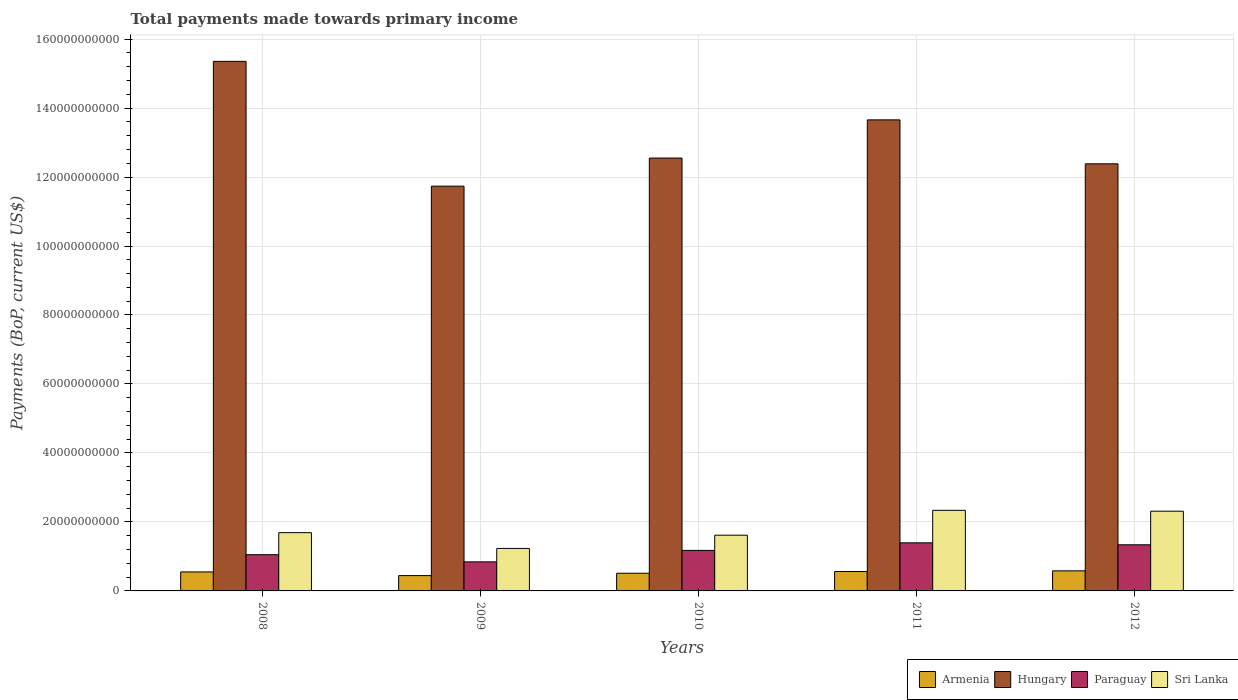Are the number of bars per tick equal to the number of legend labels?
Your answer should be very brief. Yes. How many bars are there on the 4th tick from the left?
Provide a succinct answer. 4. How many bars are there on the 1st tick from the right?
Your answer should be very brief. 4. What is the label of the 5th group of bars from the left?
Give a very brief answer. 2012. In how many cases, is the number of bars for a given year not equal to the number of legend labels?
Offer a terse response. 0. What is the total payments made towards primary income in Paraguay in 2008?
Ensure brevity in your answer.  1.05e+1. Across all years, what is the maximum total payments made towards primary income in Sri Lanka?
Your answer should be compact. 2.34e+1. Across all years, what is the minimum total payments made towards primary income in Armenia?
Offer a very short reply. 4.44e+09. In which year was the total payments made towards primary income in Sri Lanka minimum?
Offer a terse response. 2009. What is the total total payments made towards primary income in Paraguay in the graph?
Your response must be concise. 5.80e+1. What is the difference between the total payments made towards primary income in Paraguay in 2011 and that in 2012?
Provide a short and direct response. 5.66e+08. What is the difference between the total payments made towards primary income in Armenia in 2008 and the total payments made towards primary income in Paraguay in 2010?
Offer a terse response. -6.24e+09. What is the average total payments made towards primary income in Armenia per year?
Offer a terse response. 5.31e+09. In the year 2012, what is the difference between the total payments made towards primary income in Paraguay and total payments made towards primary income in Armenia?
Provide a short and direct response. 7.55e+09. What is the ratio of the total payments made towards primary income in Hungary in 2009 to that in 2012?
Provide a succinct answer. 0.95. Is the total payments made towards primary income in Paraguay in 2010 less than that in 2012?
Keep it short and to the point. Yes. What is the difference between the highest and the second highest total payments made towards primary income in Armenia?
Your answer should be very brief. 2.00e+08. What is the difference between the highest and the lowest total payments made towards primary income in Sri Lanka?
Your response must be concise. 1.10e+1. Is the sum of the total payments made towards primary income in Paraguay in 2009 and 2010 greater than the maximum total payments made towards primary income in Hungary across all years?
Your answer should be compact. No. What does the 1st bar from the left in 2011 represents?
Ensure brevity in your answer.  Armenia. What does the 1st bar from the right in 2012 represents?
Your answer should be compact. Sri Lanka. How many bars are there?
Give a very brief answer. 20. What is the difference between two consecutive major ticks on the Y-axis?
Provide a succinct answer. 2.00e+1. Where does the legend appear in the graph?
Provide a succinct answer. Bottom right. How many legend labels are there?
Provide a short and direct response. 4. How are the legend labels stacked?
Provide a succinct answer. Horizontal. What is the title of the graph?
Your answer should be very brief. Total payments made towards primary income. Does "Bhutan" appear as one of the legend labels in the graph?
Make the answer very short. No. What is the label or title of the Y-axis?
Provide a succinct answer. Payments (BoP, current US$). What is the Payments (BoP, current US$) in Armenia in 2008?
Ensure brevity in your answer.  5.51e+09. What is the Payments (BoP, current US$) of Hungary in 2008?
Your answer should be compact. 1.54e+11. What is the Payments (BoP, current US$) of Paraguay in 2008?
Offer a terse response. 1.05e+1. What is the Payments (BoP, current US$) in Sri Lanka in 2008?
Provide a short and direct response. 1.69e+1. What is the Payments (BoP, current US$) of Armenia in 2009?
Make the answer very short. 4.44e+09. What is the Payments (BoP, current US$) in Hungary in 2009?
Offer a very short reply. 1.17e+11. What is the Payments (BoP, current US$) of Paraguay in 2009?
Make the answer very short. 8.42e+09. What is the Payments (BoP, current US$) of Sri Lanka in 2009?
Your response must be concise. 1.23e+1. What is the Payments (BoP, current US$) in Armenia in 2010?
Make the answer very short. 5.13e+09. What is the Payments (BoP, current US$) of Hungary in 2010?
Your answer should be compact. 1.26e+11. What is the Payments (BoP, current US$) in Paraguay in 2010?
Provide a short and direct response. 1.17e+1. What is the Payments (BoP, current US$) of Sri Lanka in 2010?
Make the answer very short. 1.62e+1. What is the Payments (BoP, current US$) of Armenia in 2011?
Offer a very short reply. 5.62e+09. What is the Payments (BoP, current US$) of Hungary in 2011?
Offer a terse response. 1.37e+11. What is the Payments (BoP, current US$) of Paraguay in 2011?
Provide a succinct answer. 1.39e+1. What is the Payments (BoP, current US$) in Sri Lanka in 2011?
Make the answer very short. 2.34e+1. What is the Payments (BoP, current US$) of Armenia in 2012?
Offer a very short reply. 5.82e+09. What is the Payments (BoP, current US$) of Hungary in 2012?
Offer a terse response. 1.24e+11. What is the Payments (BoP, current US$) in Paraguay in 2012?
Your answer should be very brief. 1.34e+1. What is the Payments (BoP, current US$) of Sri Lanka in 2012?
Provide a succinct answer. 2.31e+1. Across all years, what is the maximum Payments (BoP, current US$) in Armenia?
Your answer should be very brief. 5.82e+09. Across all years, what is the maximum Payments (BoP, current US$) in Hungary?
Your answer should be compact. 1.54e+11. Across all years, what is the maximum Payments (BoP, current US$) of Paraguay?
Offer a terse response. 1.39e+1. Across all years, what is the maximum Payments (BoP, current US$) in Sri Lanka?
Give a very brief answer. 2.34e+1. Across all years, what is the minimum Payments (BoP, current US$) of Armenia?
Offer a very short reply. 4.44e+09. Across all years, what is the minimum Payments (BoP, current US$) in Hungary?
Give a very brief answer. 1.17e+11. Across all years, what is the minimum Payments (BoP, current US$) in Paraguay?
Offer a terse response. 8.42e+09. Across all years, what is the minimum Payments (BoP, current US$) in Sri Lanka?
Ensure brevity in your answer.  1.23e+1. What is the total Payments (BoP, current US$) in Armenia in the graph?
Ensure brevity in your answer.  2.65e+1. What is the total Payments (BoP, current US$) in Hungary in the graph?
Ensure brevity in your answer.  6.57e+11. What is the total Payments (BoP, current US$) of Paraguay in the graph?
Your response must be concise. 5.80e+1. What is the total Payments (BoP, current US$) of Sri Lanka in the graph?
Your answer should be compact. 9.19e+1. What is the difference between the Payments (BoP, current US$) in Armenia in 2008 and that in 2009?
Provide a short and direct response. 1.07e+09. What is the difference between the Payments (BoP, current US$) of Hungary in 2008 and that in 2009?
Ensure brevity in your answer.  3.62e+1. What is the difference between the Payments (BoP, current US$) of Paraguay in 2008 and that in 2009?
Offer a terse response. 2.09e+09. What is the difference between the Payments (BoP, current US$) in Sri Lanka in 2008 and that in 2009?
Provide a succinct answer. 4.57e+09. What is the difference between the Payments (BoP, current US$) in Armenia in 2008 and that in 2010?
Provide a short and direct response. 3.85e+08. What is the difference between the Payments (BoP, current US$) in Hungary in 2008 and that in 2010?
Offer a very short reply. 2.80e+1. What is the difference between the Payments (BoP, current US$) of Paraguay in 2008 and that in 2010?
Provide a succinct answer. -1.24e+09. What is the difference between the Payments (BoP, current US$) of Sri Lanka in 2008 and that in 2010?
Offer a terse response. 7.31e+08. What is the difference between the Payments (BoP, current US$) of Armenia in 2008 and that in 2011?
Your answer should be very brief. -1.10e+08. What is the difference between the Payments (BoP, current US$) of Hungary in 2008 and that in 2011?
Offer a terse response. 1.70e+1. What is the difference between the Payments (BoP, current US$) of Paraguay in 2008 and that in 2011?
Your answer should be very brief. -3.43e+09. What is the difference between the Payments (BoP, current US$) of Sri Lanka in 2008 and that in 2011?
Offer a very short reply. -6.48e+09. What is the difference between the Payments (BoP, current US$) of Armenia in 2008 and that in 2012?
Give a very brief answer. -3.10e+08. What is the difference between the Payments (BoP, current US$) in Hungary in 2008 and that in 2012?
Offer a terse response. 2.97e+1. What is the difference between the Payments (BoP, current US$) in Paraguay in 2008 and that in 2012?
Keep it short and to the point. -2.87e+09. What is the difference between the Payments (BoP, current US$) of Sri Lanka in 2008 and that in 2012?
Provide a short and direct response. -6.23e+09. What is the difference between the Payments (BoP, current US$) in Armenia in 2009 and that in 2010?
Provide a short and direct response. -6.85e+08. What is the difference between the Payments (BoP, current US$) in Hungary in 2009 and that in 2010?
Make the answer very short. -8.15e+09. What is the difference between the Payments (BoP, current US$) of Paraguay in 2009 and that in 2010?
Ensure brevity in your answer.  -3.33e+09. What is the difference between the Payments (BoP, current US$) of Sri Lanka in 2009 and that in 2010?
Your answer should be very brief. -3.84e+09. What is the difference between the Payments (BoP, current US$) in Armenia in 2009 and that in 2011?
Make the answer very short. -1.18e+09. What is the difference between the Payments (BoP, current US$) in Hungary in 2009 and that in 2011?
Your response must be concise. -1.92e+1. What is the difference between the Payments (BoP, current US$) in Paraguay in 2009 and that in 2011?
Offer a very short reply. -5.52e+09. What is the difference between the Payments (BoP, current US$) in Sri Lanka in 2009 and that in 2011?
Your answer should be very brief. -1.10e+1. What is the difference between the Payments (BoP, current US$) of Armenia in 2009 and that in 2012?
Make the answer very short. -1.38e+09. What is the difference between the Payments (BoP, current US$) in Hungary in 2009 and that in 2012?
Ensure brevity in your answer.  -6.47e+09. What is the difference between the Payments (BoP, current US$) in Paraguay in 2009 and that in 2012?
Your answer should be compact. -4.95e+09. What is the difference between the Payments (BoP, current US$) in Sri Lanka in 2009 and that in 2012?
Your answer should be compact. -1.08e+1. What is the difference between the Payments (BoP, current US$) of Armenia in 2010 and that in 2011?
Make the answer very short. -4.95e+08. What is the difference between the Payments (BoP, current US$) in Hungary in 2010 and that in 2011?
Make the answer very short. -1.11e+1. What is the difference between the Payments (BoP, current US$) in Paraguay in 2010 and that in 2011?
Offer a very short reply. -2.19e+09. What is the difference between the Payments (BoP, current US$) in Sri Lanka in 2010 and that in 2011?
Offer a very short reply. -7.21e+09. What is the difference between the Payments (BoP, current US$) in Armenia in 2010 and that in 2012?
Make the answer very short. -6.96e+08. What is the difference between the Payments (BoP, current US$) in Hungary in 2010 and that in 2012?
Your answer should be compact. 1.67e+09. What is the difference between the Payments (BoP, current US$) of Paraguay in 2010 and that in 2012?
Ensure brevity in your answer.  -1.62e+09. What is the difference between the Payments (BoP, current US$) in Sri Lanka in 2010 and that in 2012?
Provide a succinct answer. -6.96e+09. What is the difference between the Payments (BoP, current US$) in Armenia in 2011 and that in 2012?
Offer a terse response. -2.00e+08. What is the difference between the Payments (BoP, current US$) in Hungary in 2011 and that in 2012?
Give a very brief answer. 1.27e+1. What is the difference between the Payments (BoP, current US$) of Paraguay in 2011 and that in 2012?
Provide a short and direct response. 5.66e+08. What is the difference between the Payments (BoP, current US$) in Sri Lanka in 2011 and that in 2012?
Make the answer very short. 2.51e+08. What is the difference between the Payments (BoP, current US$) in Armenia in 2008 and the Payments (BoP, current US$) in Hungary in 2009?
Provide a short and direct response. -1.12e+11. What is the difference between the Payments (BoP, current US$) of Armenia in 2008 and the Payments (BoP, current US$) of Paraguay in 2009?
Your response must be concise. -2.91e+09. What is the difference between the Payments (BoP, current US$) of Armenia in 2008 and the Payments (BoP, current US$) of Sri Lanka in 2009?
Ensure brevity in your answer.  -6.80e+09. What is the difference between the Payments (BoP, current US$) of Hungary in 2008 and the Payments (BoP, current US$) of Paraguay in 2009?
Provide a short and direct response. 1.45e+11. What is the difference between the Payments (BoP, current US$) in Hungary in 2008 and the Payments (BoP, current US$) in Sri Lanka in 2009?
Make the answer very short. 1.41e+11. What is the difference between the Payments (BoP, current US$) in Paraguay in 2008 and the Payments (BoP, current US$) in Sri Lanka in 2009?
Give a very brief answer. -1.81e+09. What is the difference between the Payments (BoP, current US$) in Armenia in 2008 and the Payments (BoP, current US$) in Hungary in 2010?
Offer a terse response. -1.20e+11. What is the difference between the Payments (BoP, current US$) in Armenia in 2008 and the Payments (BoP, current US$) in Paraguay in 2010?
Your answer should be compact. -6.24e+09. What is the difference between the Payments (BoP, current US$) in Armenia in 2008 and the Payments (BoP, current US$) in Sri Lanka in 2010?
Your answer should be compact. -1.06e+1. What is the difference between the Payments (BoP, current US$) of Hungary in 2008 and the Payments (BoP, current US$) of Paraguay in 2010?
Offer a terse response. 1.42e+11. What is the difference between the Payments (BoP, current US$) in Hungary in 2008 and the Payments (BoP, current US$) in Sri Lanka in 2010?
Give a very brief answer. 1.37e+11. What is the difference between the Payments (BoP, current US$) in Paraguay in 2008 and the Payments (BoP, current US$) in Sri Lanka in 2010?
Your answer should be very brief. -5.65e+09. What is the difference between the Payments (BoP, current US$) of Armenia in 2008 and the Payments (BoP, current US$) of Hungary in 2011?
Keep it short and to the point. -1.31e+11. What is the difference between the Payments (BoP, current US$) in Armenia in 2008 and the Payments (BoP, current US$) in Paraguay in 2011?
Provide a succinct answer. -8.43e+09. What is the difference between the Payments (BoP, current US$) in Armenia in 2008 and the Payments (BoP, current US$) in Sri Lanka in 2011?
Your answer should be compact. -1.79e+1. What is the difference between the Payments (BoP, current US$) of Hungary in 2008 and the Payments (BoP, current US$) of Paraguay in 2011?
Your response must be concise. 1.40e+11. What is the difference between the Payments (BoP, current US$) in Hungary in 2008 and the Payments (BoP, current US$) in Sri Lanka in 2011?
Provide a succinct answer. 1.30e+11. What is the difference between the Payments (BoP, current US$) in Paraguay in 2008 and the Payments (BoP, current US$) in Sri Lanka in 2011?
Keep it short and to the point. -1.29e+1. What is the difference between the Payments (BoP, current US$) of Armenia in 2008 and the Payments (BoP, current US$) of Hungary in 2012?
Provide a short and direct response. -1.18e+11. What is the difference between the Payments (BoP, current US$) of Armenia in 2008 and the Payments (BoP, current US$) of Paraguay in 2012?
Offer a terse response. -7.86e+09. What is the difference between the Payments (BoP, current US$) in Armenia in 2008 and the Payments (BoP, current US$) in Sri Lanka in 2012?
Keep it short and to the point. -1.76e+1. What is the difference between the Payments (BoP, current US$) in Hungary in 2008 and the Payments (BoP, current US$) in Paraguay in 2012?
Offer a very short reply. 1.40e+11. What is the difference between the Payments (BoP, current US$) of Hungary in 2008 and the Payments (BoP, current US$) of Sri Lanka in 2012?
Offer a very short reply. 1.30e+11. What is the difference between the Payments (BoP, current US$) of Paraguay in 2008 and the Payments (BoP, current US$) of Sri Lanka in 2012?
Provide a succinct answer. -1.26e+1. What is the difference between the Payments (BoP, current US$) in Armenia in 2009 and the Payments (BoP, current US$) in Hungary in 2010?
Keep it short and to the point. -1.21e+11. What is the difference between the Payments (BoP, current US$) in Armenia in 2009 and the Payments (BoP, current US$) in Paraguay in 2010?
Offer a terse response. -7.31e+09. What is the difference between the Payments (BoP, current US$) of Armenia in 2009 and the Payments (BoP, current US$) of Sri Lanka in 2010?
Provide a short and direct response. -1.17e+1. What is the difference between the Payments (BoP, current US$) in Hungary in 2009 and the Payments (BoP, current US$) in Paraguay in 2010?
Provide a short and direct response. 1.06e+11. What is the difference between the Payments (BoP, current US$) of Hungary in 2009 and the Payments (BoP, current US$) of Sri Lanka in 2010?
Your answer should be compact. 1.01e+11. What is the difference between the Payments (BoP, current US$) of Paraguay in 2009 and the Payments (BoP, current US$) of Sri Lanka in 2010?
Provide a short and direct response. -7.74e+09. What is the difference between the Payments (BoP, current US$) in Armenia in 2009 and the Payments (BoP, current US$) in Hungary in 2011?
Your answer should be compact. -1.32e+11. What is the difference between the Payments (BoP, current US$) in Armenia in 2009 and the Payments (BoP, current US$) in Paraguay in 2011?
Offer a very short reply. -9.50e+09. What is the difference between the Payments (BoP, current US$) in Armenia in 2009 and the Payments (BoP, current US$) in Sri Lanka in 2011?
Offer a terse response. -1.89e+1. What is the difference between the Payments (BoP, current US$) in Hungary in 2009 and the Payments (BoP, current US$) in Paraguay in 2011?
Give a very brief answer. 1.03e+11. What is the difference between the Payments (BoP, current US$) of Hungary in 2009 and the Payments (BoP, current US$) of Sri Lanka in 2011?
Your answer should be very brief. 9.40e+1. What is the difference between the Payments (BoP, current US$) of Paraguay in 2009 and the Payments (BoP, current US$) of Sri Lanka in 2011?
Your answer should be compact. -1.49e+1. What is the difference between the Payments (BoP, current US$) of Armenia in 2009 and the Payments (BoP, current US$) of Hungary in 2012?
Your answer should be compact. -1.19e+11. What is the difference between the Payments (BoP, current US$) of Armenia in 2009 and the Payments (BoP, current US$) of Paraguay in 2012?
Your answer should be compact. -8.93e+09. What is the difference between the Payments (BoP, current US$) in Armenia in 2009 and the Payments (BoP, current US$) in Sri Lanka in 2012?
Your answer should be very brief. -1.87e+1. What is the difference between the Payments (BoP, current US$) in Hungary in 2009 and the Payments (BoP, current US$) in Paraguay in 2012?
Provide a short and direct response. 1.04e+11. What is the difference between the Payments (BoP, current US$) of Hungary in 2009 and the Payments (BoP, current US$) of Sri Lanka in 2012?
Your answer should be very brief. 9.42e+1. What is the difference between the Payments (BoP, current US$) in Paraguay in 2009 and the Payments (BoP, current US$) in Sri Lanka in 2012?
Provide a short and direct response. -1.47e+1. What is the difference between the Payments (BoP, current US$) in Armenia in 2010 and the Payments (BoP, current US$) in Hungary in 2011?
Ensure brevity in your answer.  -1.31e+11. What is the difference between the Payments (BoP, current US$) of Armenia in 2010 and the Payments (BoP, current US$) of Paraguay in 2011?
Give a very brief answer. -8.81e+09. What is the difference between the Payments (BoP, current US$) in Armenia in 2010 and the Payments (BoP, current US$) in Sri Lanka in 2011?
Offer a very short reply. -1.82e+1. What is the difference between the Payments (BoP, current US$) in Hungary in 2010 and the Payments (BoP, current US$) in Paraguay in 2011?
Provide a short and direct response. 1.12e+11. What is the difference between the Payments (BoP, current US$) of Hungary in 2010 and the Payments (BoP, current US$) of Sri Lanka in 2011?
Your response must be concise. 1.02e+11. What is the difference between the Payments (BoP, current US$) of Paraguay in 2010 and the Payments (BoP, current US$) of Sri Lanka in 2011?
Ensure brevity in your answer.  -1.16e+1. What is the difference between the Payments (BoP, current US$) of Armenia in 2010 and the Payments (BoP, current US$) of Hungary in 2012?
Keep it short and to the point. -1.19e+11. What is the difference between the Payments (BoP, current US$) of Armenia in 2010 and the Payments (BoP, current US$) of Paraguay in 2012?
Ensure brevity in your answer.  -8.25e+09. What is the difference between the Payments (BoP, current US$) of Armenia in 2010 and the Payments (BoP, current US$) of Sri Lanka in 2012?
Ensure brevity in your answer.  -1.80e+1. What is the difference between the Payments (BoP, current US$) in Hungary in 2010 and the Payments (BoP, current US$) in Paraguay in 2012?
Ensure brevity in your answer.  1.12e+11. What is the difference between the Payments (BoP, current US$) in Hungary in 2010 and the Payments (BoP, current US$) in Sri Lanka in 2012?
Keep it short and to the point. 1.02e+11. What is the difference between the Payments (BoP, current US$) of Paraguay in 2010 and the Payments (BoP, current US$) of Sri Lanka in 2012?
Your answer should be very brief. -1.14e+1. What is the difference between the Payments (BoP, current US$) of Armenia in 2011 and the Payments (BoP, current US$) of Hungary in 2012?
Provide a short and direct response. -1.18e+11. What is the difference between the Payments (BoP, current US$) in Armenia in 2011 and the Payments (BoP, current US$) in Paraguay in 2012?
Your answer should be compact. -7.75e+09. What is the difference between the Payments (BoP, current US$) of Armenia in 2011 and the Payments (BoP, current US$) of Sri Lanka in 2012?
Give a very brief answer. -1.75e+1. What is the difference between the Payments (BoP, current US$) in Hungary in 2011 and the Payments (BoP, current US$) in Paraguay in 2012?
Your answer should be very brief. 1.23e+11. What is the difference between the Payments (BoP, current US$) of Hungary in 2011 and the Payments (BoP, current US$) of Sri Lanka in 2012?
Provide a succinct answer. 1.13e+11. What is the difference between the Payments (BoP, current US$) of Paraguay in 2011 and the Payments (BoP, current US$) of Sri Lanka in 2012?
Your answer should be compact. -9.18e+09. What is the average Payments (BoP, current US$) of Armenia per year?
Your response must be concise. 5.31e+09. What is the average Payments (BoP, current US$) of Hungary per year?
Give a very brief answer. 1.31e+11. What is the average Payments (BoP, current US$) of Paraguay per year?
Ensure brevity in your answer.  1.16e+1. What is the average Payments (BoP, current US$) in Sri Lanka per year?
Keep it short and to the point. 1.84e+1. In the year 2008, what is the difference between the Payments (BoP, current US$) of Armenia and Payments (BoP, current US$) of Hungary?
Your answer should be compact. -1.48e+11. In the year 2008, what is the difference between the Payments (BoP, current US$) of Armenia and Payments (BoP, current US$) of Paraguay?
Your answer should be very brief. -5.00e+09. In the year 2008, what is the difference between the Payments (BoP, current US$) of Armenia and Payments (BoP, current US$) of Sri Lanka?
Keep it short and to the point. -1.14e+1. In the year 2008, what is the difference between the Payments (BoP, current US$) in Hungary and Payments (BoP, current US$) in Paraguay?
Your answer should be compact. 1.43e+11. In the year 2008, what is the difference between the Payments (BoP, current US$) in Hungary and Payments (BoP, current US$) in Sri Lanka?
Give a very brief answer. 1.37e+11. In the year 2008, what is the difference between the Payments (BoP, current US$) of Paraguay and Payments (BoP, current US$) of Sri Lanka?
Your answer should be compact. -6.38e+09. In the year 2009, what is the difference between the Payments (BoP, current US$) in Armenia and Payments (BoP, current US$) in Hungary?
Keep it short and to the point. -1.13e+11. In the year 2009, what is the difference between the Payments (BoP, current US$) in Armenia and Payments (BoP, current US$) in Paraguay?
Provide a succinct answer. -3.98e+09. In the year 2009, what is the difference between the Payments (BoP, current US$) of Armenia and Payments (BoP, current US$) of Sri Lanka?
Offer a very short reply. -7.88e+09. In the year 2009, what is the difference between the Payments (BoP, current US$) in Hungary and Payments (BoP, current US$) in Paraguay?
Give a very brief answer. 1.09e+11. In the year 2009, what is the difference between the Payments (BoP, current US$) in Hungary and Payments (BoP, current US$) in Sri Lanka?
Provide a succinct answer. 1.05e+11. In the year 2009, what is the difference between the Payments (BoP, current US$) in Paraguay and Payments (BoP, current US$) in Sri Lanka?
Make the answer very short. -3.89e+09. In the year 2010, what is the difference between the Payments (BoP, current US$) in Armenia and Payments (BoP, current US$) in Hungary?
Provide a succinct answer. -1.20e+11. In the year 2010, what is the difference between the Payments (BoP, current US$) in Armenia and Payments (BoP, current US$) in Paraguay?
Ensure brevity in your answer.  -6.62e+09. In the year 2010, what is the difference between the Payments (BoP, current US$) in Armenia and Payments (BoP, current US$) in Sri Lanka?
Your answer should be compact. -1.10e+1. In the year 2010, what is the difference between the Payments (BoP, current US$) in Hungary and Payments (BoP, current US$) in Paraguay?
Your answer should be compact. 1.14e+11. In the year 2010, what is the difference between the Payments (BoP, current US$) of Hungary and Payments (BoP, current US$) of Sri Lanka?
Give a very brief answer. 1.09e+11. In the year 2010, what is the difference between the Payments (BoP, current US$) in Paraguay and Payments (BoP, current US$) in Sri Lanka?
Your answer should be compact. -4.41e+09. In the year 2011, what is the difference between the Payments (BoP, current US$) of Armenia and Payments (BoP, current US$) of Hungary?
Keep it short and to the point. -1.31e+11. In the year 2011, what is the difference between the Payments (BoP, current US$) in Armenia and Payments (BoP, current US$) in Paraguay?
Offer a very short reply. -8.32e+09. In the year 2011, what is the difference between the Payments (BoP, current US$) in Armenia and Payments (BoP, current US$) in Sri Lanka?
Provide a succinct answer. -1.77e+1. In the year 2011, what is the difference between the Payments (BoP, current US$) in Hungary and Payments (BoP, current US$) in Paraguay?
Offer a terse response. 1.23e+11. In the year 2011, what is the difference between the Payments (BoP, current US$) in Hungary and Payments (BoP, current US$) in Sri Lanka?
Offer a very short reply. 1.13e+11. In the year 2011, what is the difference between the Payments (BoP, current US$) of Paraguay and Payments (BoP, current US$) of Sri Lanka?
Provide a short and direct response. -9.43e+09. In the year 2012, what is the difference between the Payments (BoP, current US$) of Armenia and Payments (BoP, current US$) of Hungary?
Your answer should be compact. -1.18e+11. In the year 2012, what is the difference between the Payments (BoP, current US$) of Armenia and Payments (BoP, current US$) of Paraguay?
Provide a succinct answer. -7.55e+09. In the year 2012, what is the difference between the Payments (BoP, current US$) of Armenia and Payments (BoP, current US$) of Sri Lanka?
Give a very brief answer. -1.73e+1. In the year 2012, what is the difference between the Payments (BoP, current US$) in Hungary and Payments (BoP, current US$) in Paraguay?
Offer a very short reply. 1.10e+11. In the year 2012, what is the difference between the Payments (BoP, current US$) of Hungary and Payments (BoP, current US$) of Sri Lanka?
Your answer should be compact. 1.01e+11. In the year 2012, what is the difference between the Payments (BoP, current US$) of Paraguay and Payments (BoP, current US$) of Sri Lanka?
Give a very brief answer. -9.74e+09. What is the ratio of the Payments (BoP, current US$) of Armenia in 2008 to that in 2009?
Provide a succinct answer. 1.24. What is the ratio of the Payments (BoP, current US$) of Hungary in 2008 to that in 2009?
Give a very brief answer. 1.31. What is the ratio of the Payments (BoP, current US$) of Paraguay in 2008 to that in 2009?
Your answer should be compact. 1.25. What is the ratio of the Payments (BoP, current US$) of Sri Lanka in 2008 to that in 2009?
Make the answer very short. 1.37. What is the ratio of the Payments (BoP, current US$) of Armenia in 2008 to that in 2010?
Your answer should be compact. 1.08. What is the ratio of the Payments (BoP, current US$) in Hungary in 2008 to that in 2010?
Your response must be concise. 1.22. What is the ratio of the Payments (BoP, current US$) of Paraguay in 2008 to that in 2010?
Make the answer very short. 0.89. What is the ratio of the Payments (BoP, current US$) in Sri Lanka in 2008 to that in 2010?
Offer a terse response. 1.05. What is the ratio of the Payments (BoP, current US$) of Armenia in 2008 to that in 2011?
Your answer should be compact. 0.98. What is the ratio of the Payments (BoP, current US$) in Hungary in 2008 to that in 2011?
Ensure brevity in your answer.  1.12. What is the ratio of the Payments (BoP, current US$) of Paraguay in 2008 to that in 2011?
Provide a succinct answer. 0.75. What is the ratio of the Payments (BoP, current US$) of Sri Lanka in 2008 to that in 2011?
Give a very brief answer. 0.72. What is the ratio of the Payments (BoP, current US$) of Armenia in 2008 to that in 2012?
Keep it short and to the point. 0.95. What is the ratio of the Payments (BoP, current US$) of Hungary in 2008 to that in 2012?
Offer a terse response. 1.24. What is the ratio of the Payments (BoP, current US$) in Paraguay in 2008 to that in 2012?
Ensure brevity in your answer.  0.79. What is the ratio of the Payments (BoP, current US$) in Sri Lanka in 2008 to that in 2012?
Your answer should be very brief. 0.73. What is the ratio of the Payments (BoP, current US$) in Armenia in 2009 to that in 2010?
Provide a short and direct response. 0.87. What is the ratio of the Payments (BoP, current US$) in Hungary in 2009 to that in 2010?
Provide a short and direct response. 0.94. What is the ratio of the Payments (BoP, current US$) in Paraguay in 2009 to that in 2010?
Your response must be concise. 0.72. What is the ratio of the Payments (BoP, current US$) in Sri Lanka in 2009 to that in 2010?
Provide a succinct answer. 0.76. What is the ratio of the Payments (BoP, current US$) in Armenia in 2009 to that in 2011?
Your answer should be compact. 0.79. What is the ratio of the Payments (BoP, current US$) of Hungary in 2009 to that in 2011?
Offer a terse response. 0.86. What is the ratio of the Payments (BoP, current US$) of Paraguay in 2009 to that in 2011?
Your answer should be very brief. 0.6. What is the ratio of the Payments (BoP, current US$) in Sri Lanka in 2009 to that in 2011?
Give a very brief answer. 0.53. What is the ratio of the Payments (BoP, current US$) in Armenia in 2009 to that in 2012?
Your response must be concise. 0.76. What is the ratio of the Payments (BoP, current US$) in Hungary in 2009 to that in 2012?
Offer a very short reply. 0.95. What is the ratio of the Payments (BoP, current US$) of Paraguay in 2009 to that in 2012?
Offer a terse response. 0.63. What is the ratio of the Payments (BoP, current US$) of Sri Lanka in 2009 to that in 2012?
Make the answer very short. 0.53. What is the ratio of the Payments (BoP, current US$) in Armenia in 2010 to that in 2011?
Offer a terse response. 0.91. What is the ratio of the Payments (BoP, current US$) of Hungary in 2010 to that in 2011?
Provide a short and direct response. 0.92. What is the ratio of the Payments (BoP, current US$) in Paraguay in 2010 to that in 2011?
Make the answer very short. 0.84. What is the ratio of the Payments (BoP, current US$) of Sri Lanka in 2010 to that in 2011?
Your answer should be very brief. 0.69. What is the ratio of the Payments (BoP, current US$) of Armenia in 2010 to that in 2012?
Your response must be concise. 0.88. What is the ratio of the Payments (BoP, current US$) of Hungary in 2010 to that in 2012?
Ensure brevity in your answer.  1.01. What is the ratio of the Payments (BoP, current US$) of Paraguay in 2010 to that in 2012?
Your answer should be very brief. 0.88. What is the ratio of the Payments (BoP, current US$) of Sri Lanka in 2010 to that in 2012?
Offer a very short reply. 0.7. What is the ratio of the Payments (BoP, current US$) in Armenia in 2011 to that in 2012?
Provide a succinct answer. 0.97. What is the ratio of the Payments (BoP, current US$) of Hungary in 2011 to that in 2012?
Your response must be concise. 1.1. What is the ratio of the Payments (BoP, current US$) of Paraguay in 2011 to that in 2012?
Your answer should be very brief. 1.04. What is the ratio of the Payments (BoP, current US$) of Sri Lanka in 2011 to that in 2012?
Provide a succinct answer. 1.01. What is the difference between the highest and the second highest Payments (BoP, current US$) of Armenia?
Your answer should be compact. 2.00e+08. What is the difference between the highest and the second highest Payments (BoP, current US$) in Hungary?
Ensure brevity in your answer.  1.70e+1. What is the difference between the highest and the second highest Payments (BoP, current US$) of Paraguay?
Provide a short and direct response. 5.66e+08. What is the difference between the highest and the second highest Payments (BoP, current US$) in Sri Lanka?
Offer a terse response. 2.51e+08. What is the difference between the highest and the lowest Payments (BoP, current US$) of Armenia?
Your answer should be compact. 1.38e+09. What is the difference between the highest and the lowest Payments (BoP, current US$) in Hungary?
Give a very brief answer. 3.62e+1. What is the difference between the highest and the lowest Payments (BoP, current US$) in Paraguay?
Ensure brevity in your answer.  5.52e+09. What is the difference between the highest and the lowest Payments (BoP, current US$) of Sri Lanka?
Your response must be concise. 1.10e+1. 